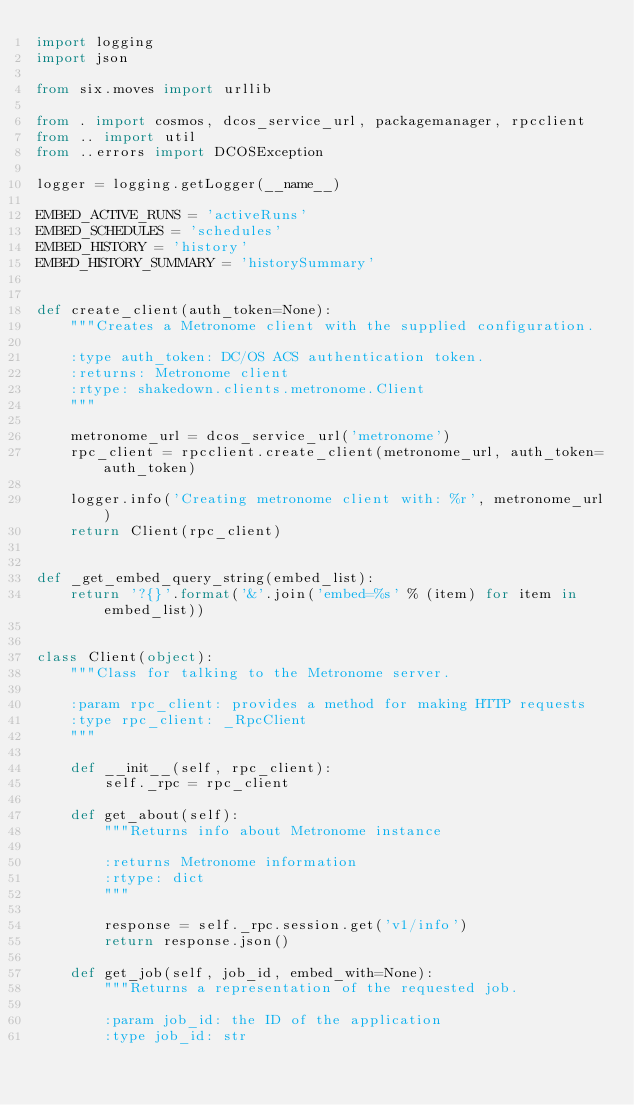<code> <loc_0><loc_0><loc_500><loc_500><_Python_>import logging
import json

from six.moves import urllib

from . import cosmos, dcos_service_url, packagemanager, rpcclient
from .. import util
from ..errors import DCOSException

logger = logging.getLogger(__name__)

EMBED_ACTIVE_RUNS = 'activeRuns'
EMBED_SCHEDULES = 'schedules'
EMBED_HISTORY = 'history'
EMBED_HISTORY_SUMMARY = 'historySummary'


def create_client(auth_token=None):
    """Creates a Metronome client with the supplied configuration.

    :type auth_token: DC/OS ACS authentication token.
    :returns: Metronome client
    :rtype: shakedown.clients.metronome.Client
    """

    metronome_url = dcos_service_url('metronome')
    rpc_client = rpcclient.create_client(metronome_url, auth_token=auth_token)

    logger.info('Creating metronome client with: %r', metronome_url)
    return Client(rpc_client)


def _get_embed_query_string(embed_list):
    return '?{}'.format('&'.join('embed=%s' % (item) for item in embed_list))


class Client(object):
    """Class for talking to the Metronome server.

    :param rpc_client: provides a method for making HTTP requests
    :type rpc_client: _RpcClient
    """

    def __init__(self, rpc_client):
        self._rpc = rpc_client

    def get_about(self):
        """Returns info about Metronome instance

        :returns Metronome information
        :rtype: dict
        """

        response = self._rpc.session.get('v1/info')
        return response.json()

    def get_job(self, job_id, embed_with=None):
        """Returns a representation of the requested job.

        :param job_id: the ID of the application
        :type job_id: str</code> 